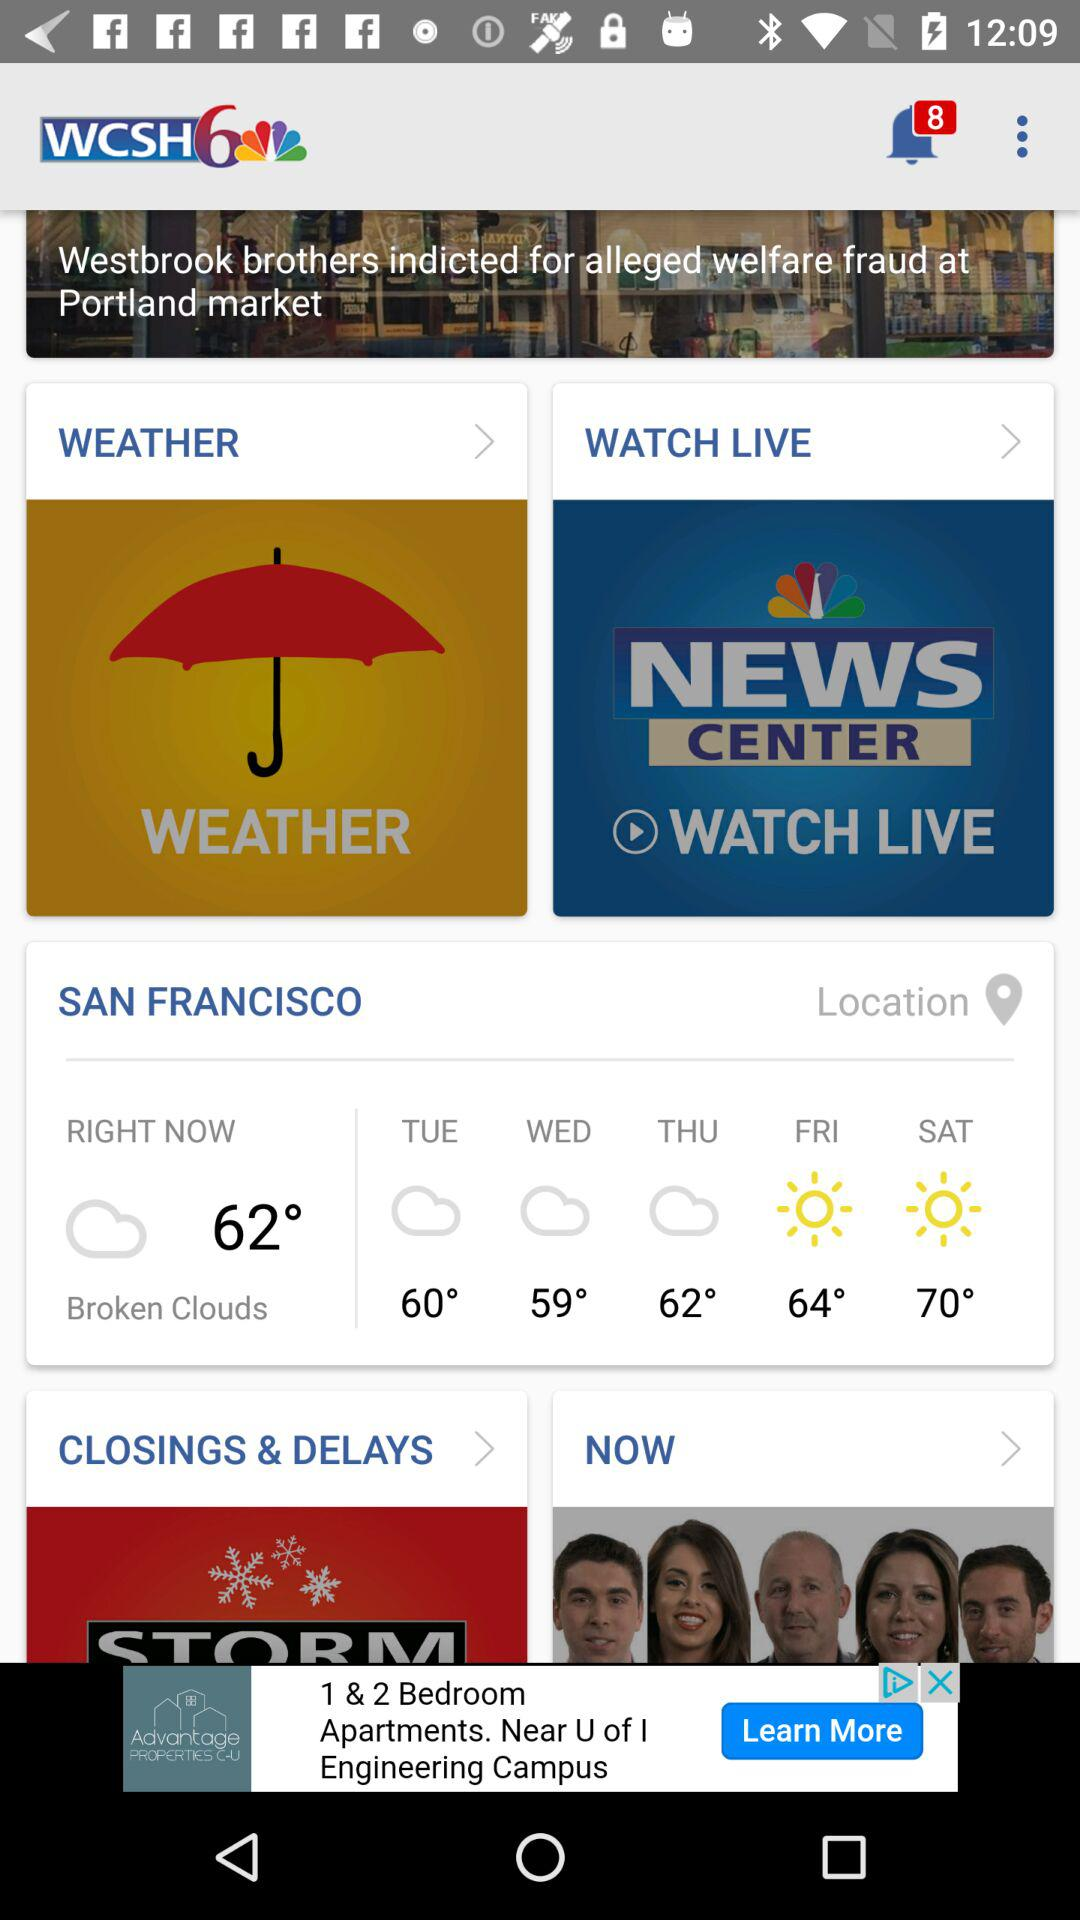What is the name of application? The name of the application is "WCSH6". 